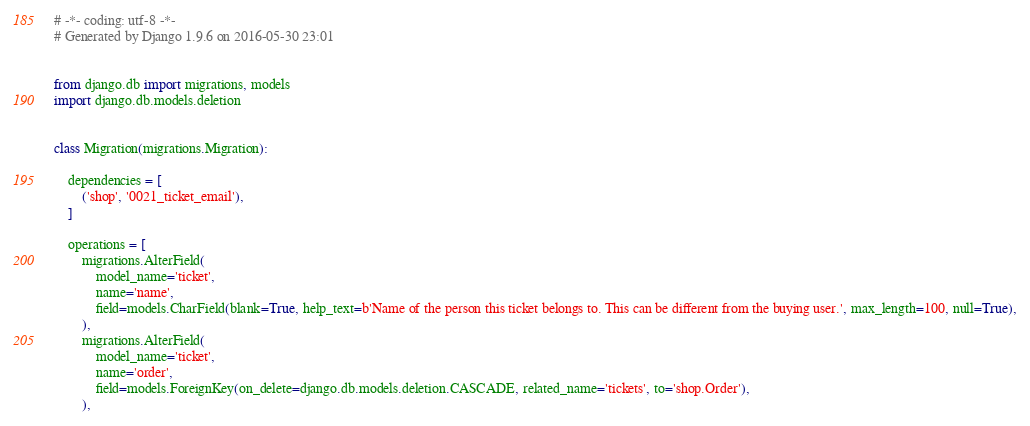Convert code to text. <code><loc_0><loc_0><loc_500><loc_500><_Python_># -*- coding: utf-8 -*-
# Generated by Django 1.9.6 on 2016-05-30 23:01


from django.db import migrations, models
import django.db.models.deletion


class Migration(migrations.Migration):

    dependencies = [
        ('shop', '0021_ticket_email'),
    ]

    operations = [
        migrations.AlterField(
            model_name='ticket',
            name='name',
            field=models.CharField(blank=True, help_text=b'Name of the person this ticket belongs to. This can be different from the buying user.', max_length=100, null=True),
        ),
        migrations.AlterField(
            model_name='ticket',
            name='order',
            field=models.ForeignKey(on_delete=django.db.models.deletion.CASCADE, related_name='tickets', to='shop.Order'),
        ),</code> 